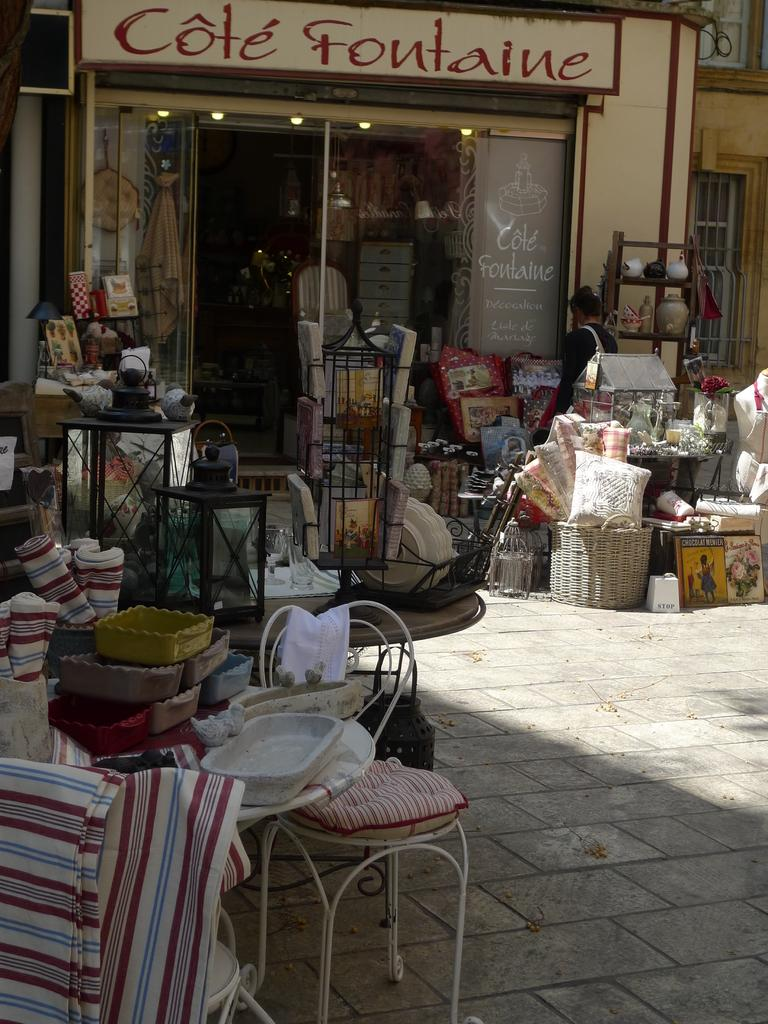What type of store is shown in the image? The image depicts a furniture store. What items can be seen in the store? There are pillows, baskets, chairs, and other types of furniture in the store. Can you describe the window in the background of the image? There is a window in the background of the image, but no specific details are provided about it. What is your sister's relation to the furniture store in the image? There is no mention of a sister in the image or the provided facts, so it is not possible to answer this question. 